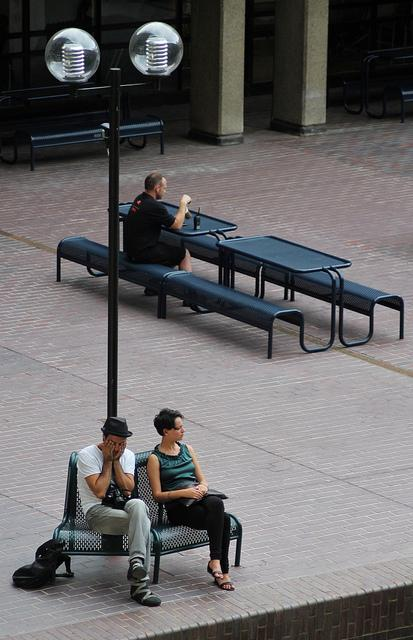What is the man at the table doing?

Choices:
A) drinking
B) jumping
C) sleeping
D) standing drinking 